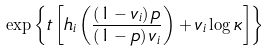<formula> <loc_0><loc_0><loc_500><loc_500>\exp \left \{ t \left [ h _ { i } \left ( \frac { \left ( 1 - v _ { i } \right ) p } { \left ( 1 - p \right ) v _ { i } } \right ) + v _ { i } \log \kappa \right ] \right \}</formula> 